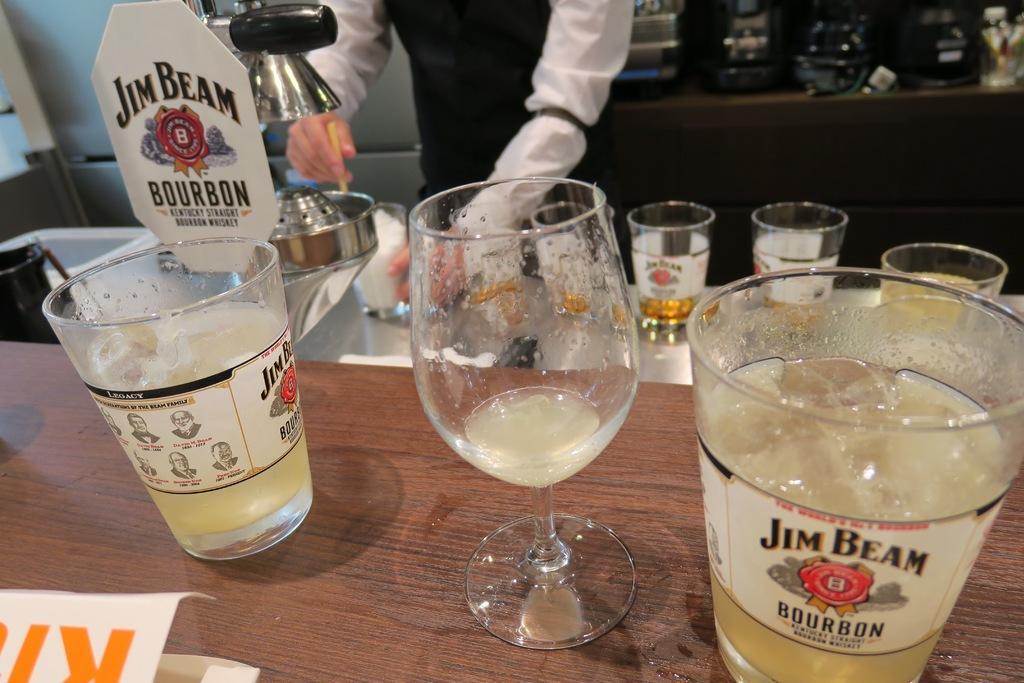In one or two sentences, can you explain what this image depicts? In this picture there are some wine glasses on the table top. Behind there is a waiter wearing black and white color shirt preparing the wine from the silver machine. 